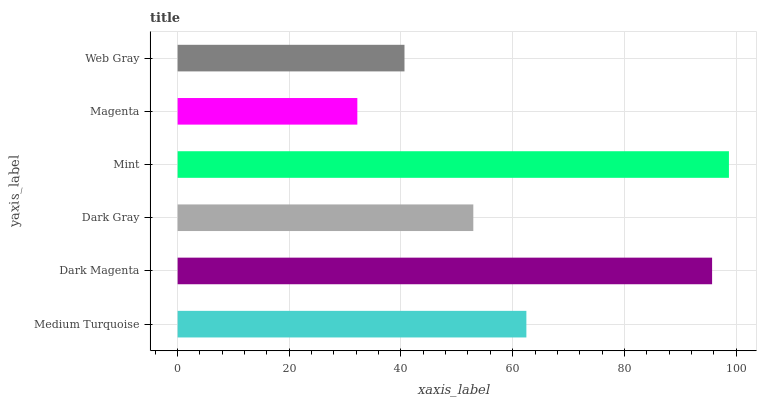Is Magenta the minimum?
Answer yes or no. Yes. Is Mint the maximum?
Answer yes or no. Yes. Is Dark Magenta the minimum?
Answer yes or no. No. Is Dark Magenta the maximum?
Answer yes or no. No. Is Dark Magenta greater than Medium Turquoise?
Answer yes or no. Yes. Is Medium Turquoise less than Dark Magenta?
Answer yes or no. Yes. Is Medium Turquoise greater than Dark Magenta?
Answer yes or no. No. Is Dark Magenta less than Medium Turquoise?
Answer yes or no. No. Is Medium Turquoise the high median?
Answer yes or no. Yes. Is Dark Gray the low median?
Answer yes or no. Yes. Is Dark Gray the high median?
Answer yes or no. No. Is Medium Turquoise the low median?
Answer yes or no. No. 